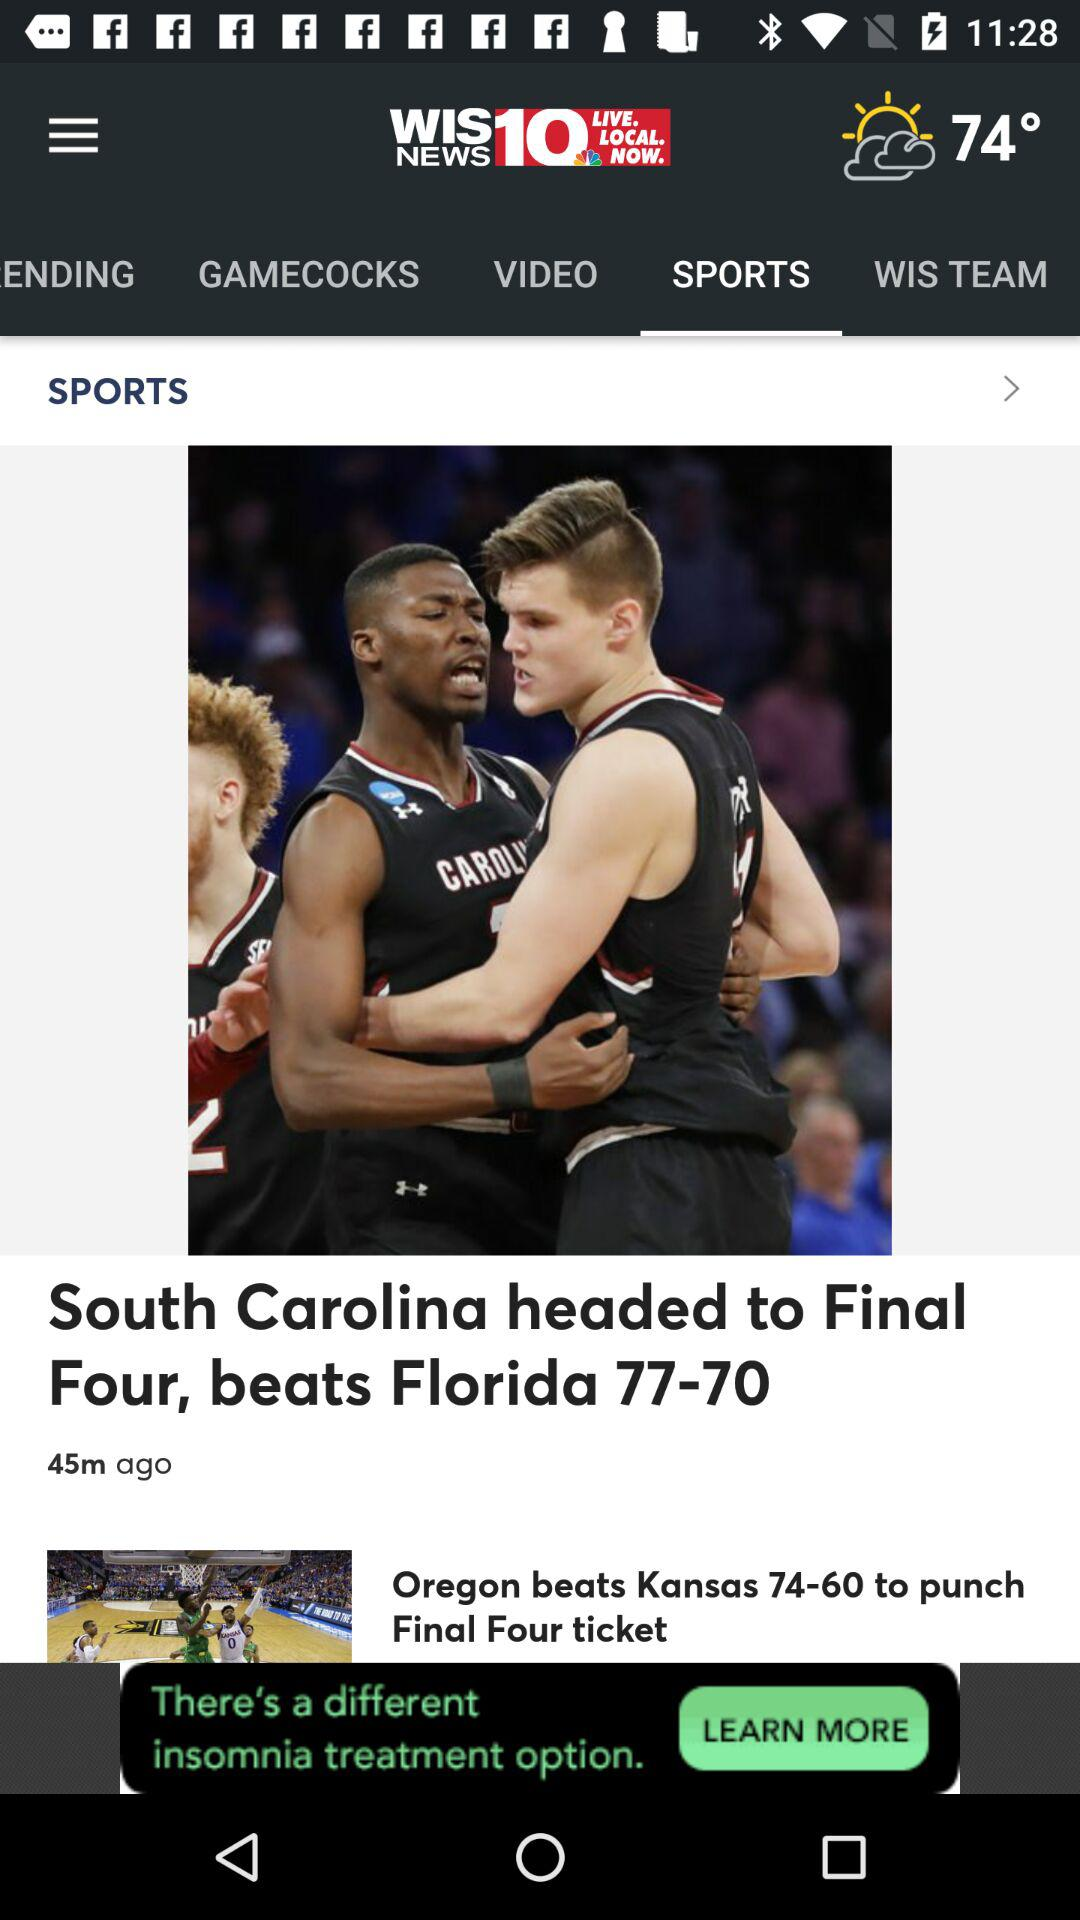Which team did "South Carolina" beat? "South Carolina" beat "Florida". 